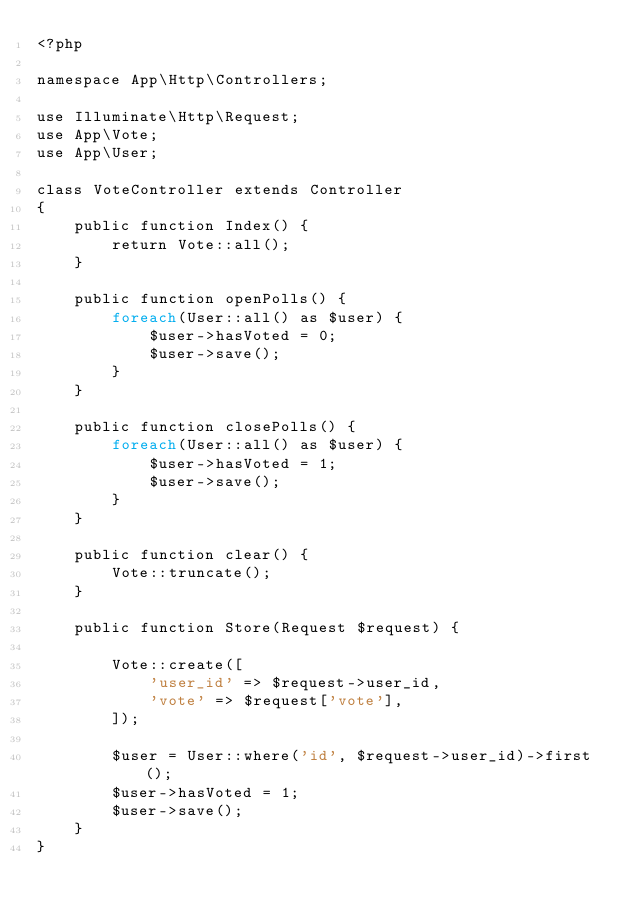Convert code to text. <code><loc_0><loc_0><loc_500><loc_500><_PHP_><?php

namespace App\Http\Controllers;

use Illuminate\Http\Request;
use App\Vote;
use App\User;

class VoteController extends Controller
{
    public function Index() {
        return Vote::all();
    }

    public function openPolls() {
        foreach(User::all() as $user) {
            $user->hasVoted = 0;
            $user->save();
        }
    }

    public function closePolls() {
        foreach(User::all() as $user) {
            $user->hasVoted = 1;
            $user->save();
        }
    }

    public function clear() {
        Vote::truncate();
    }

    public function Store(Request $request) {
        
        Vote::create([
            'user_id' => $request->user_id,
            'vote' => $request['vote'],
        ]);  

        $user = User::where('id', $request->user_id)->first();
        $user->hasVoted = 1; 
        $user->save();
    }
}
</code> 